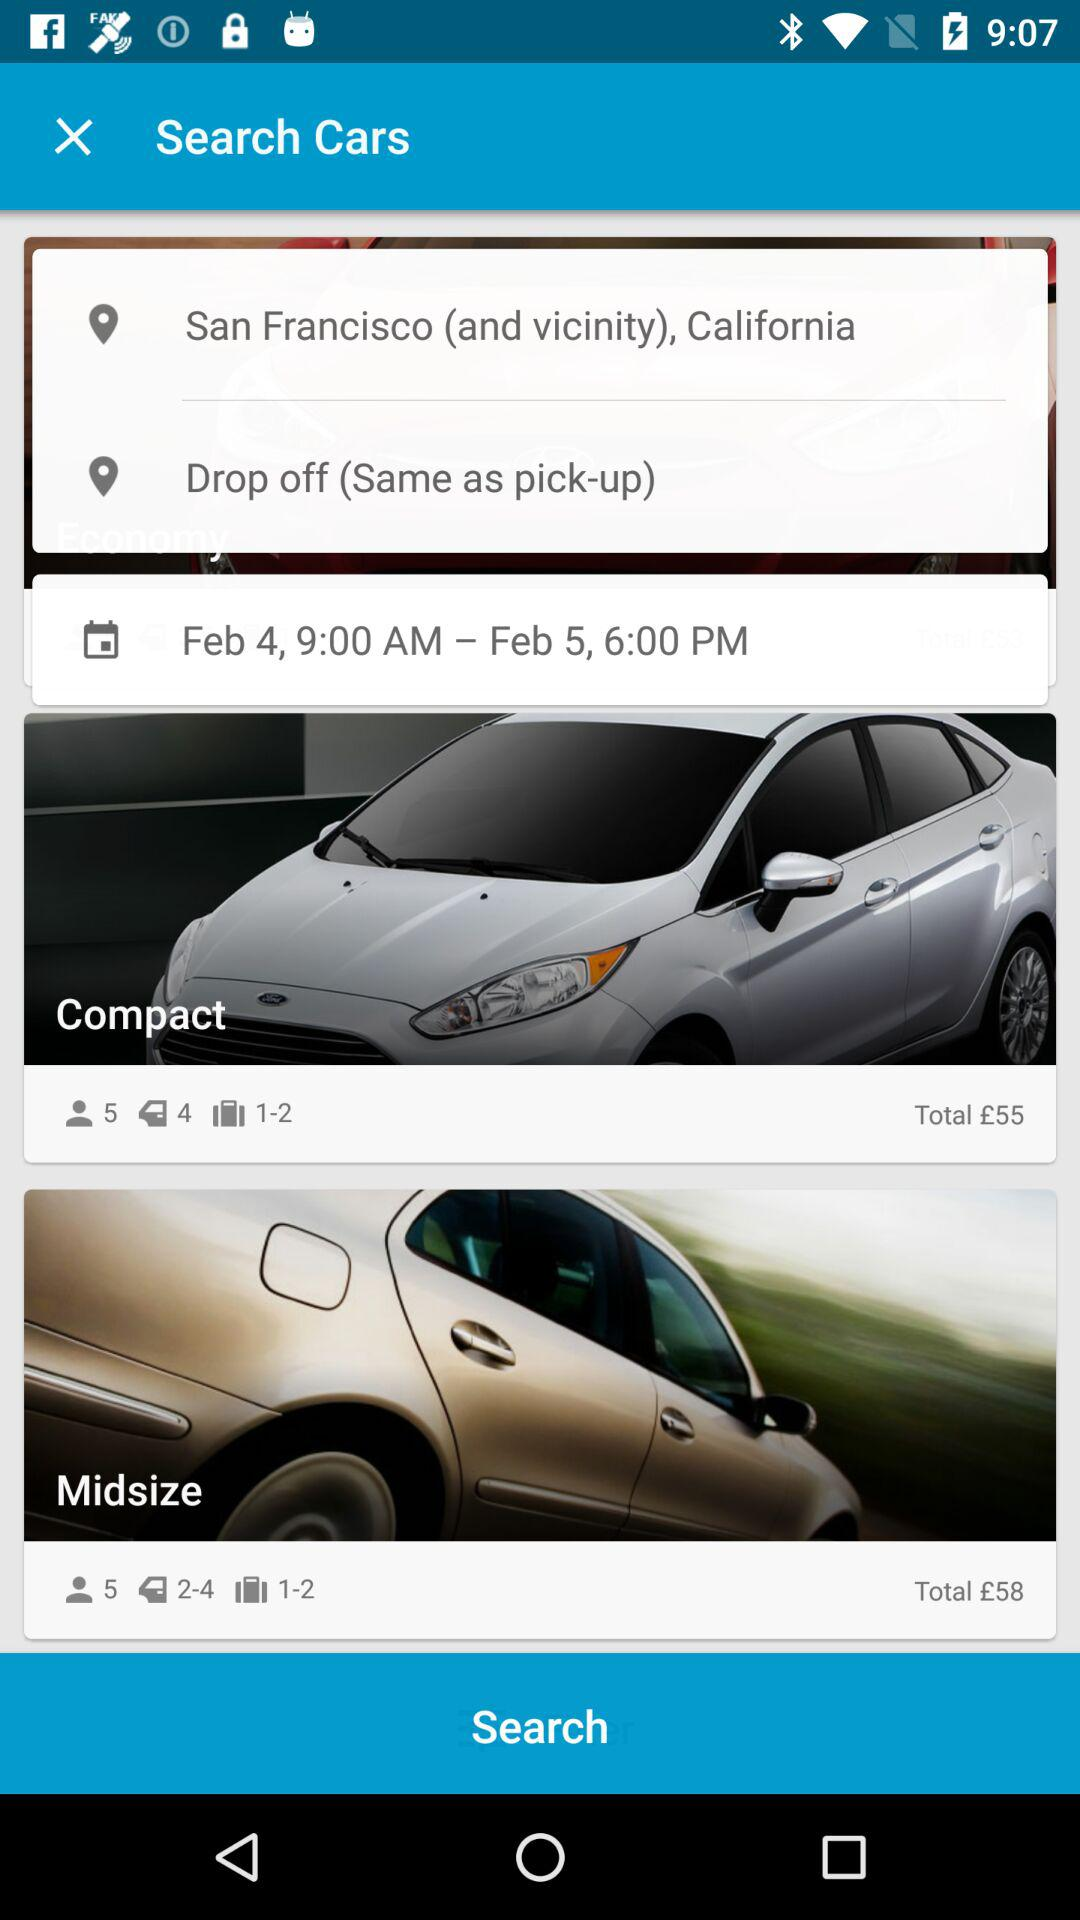How much more does the midsize car cost than the compact car?
Answer the question using a single word or phrase. £3 